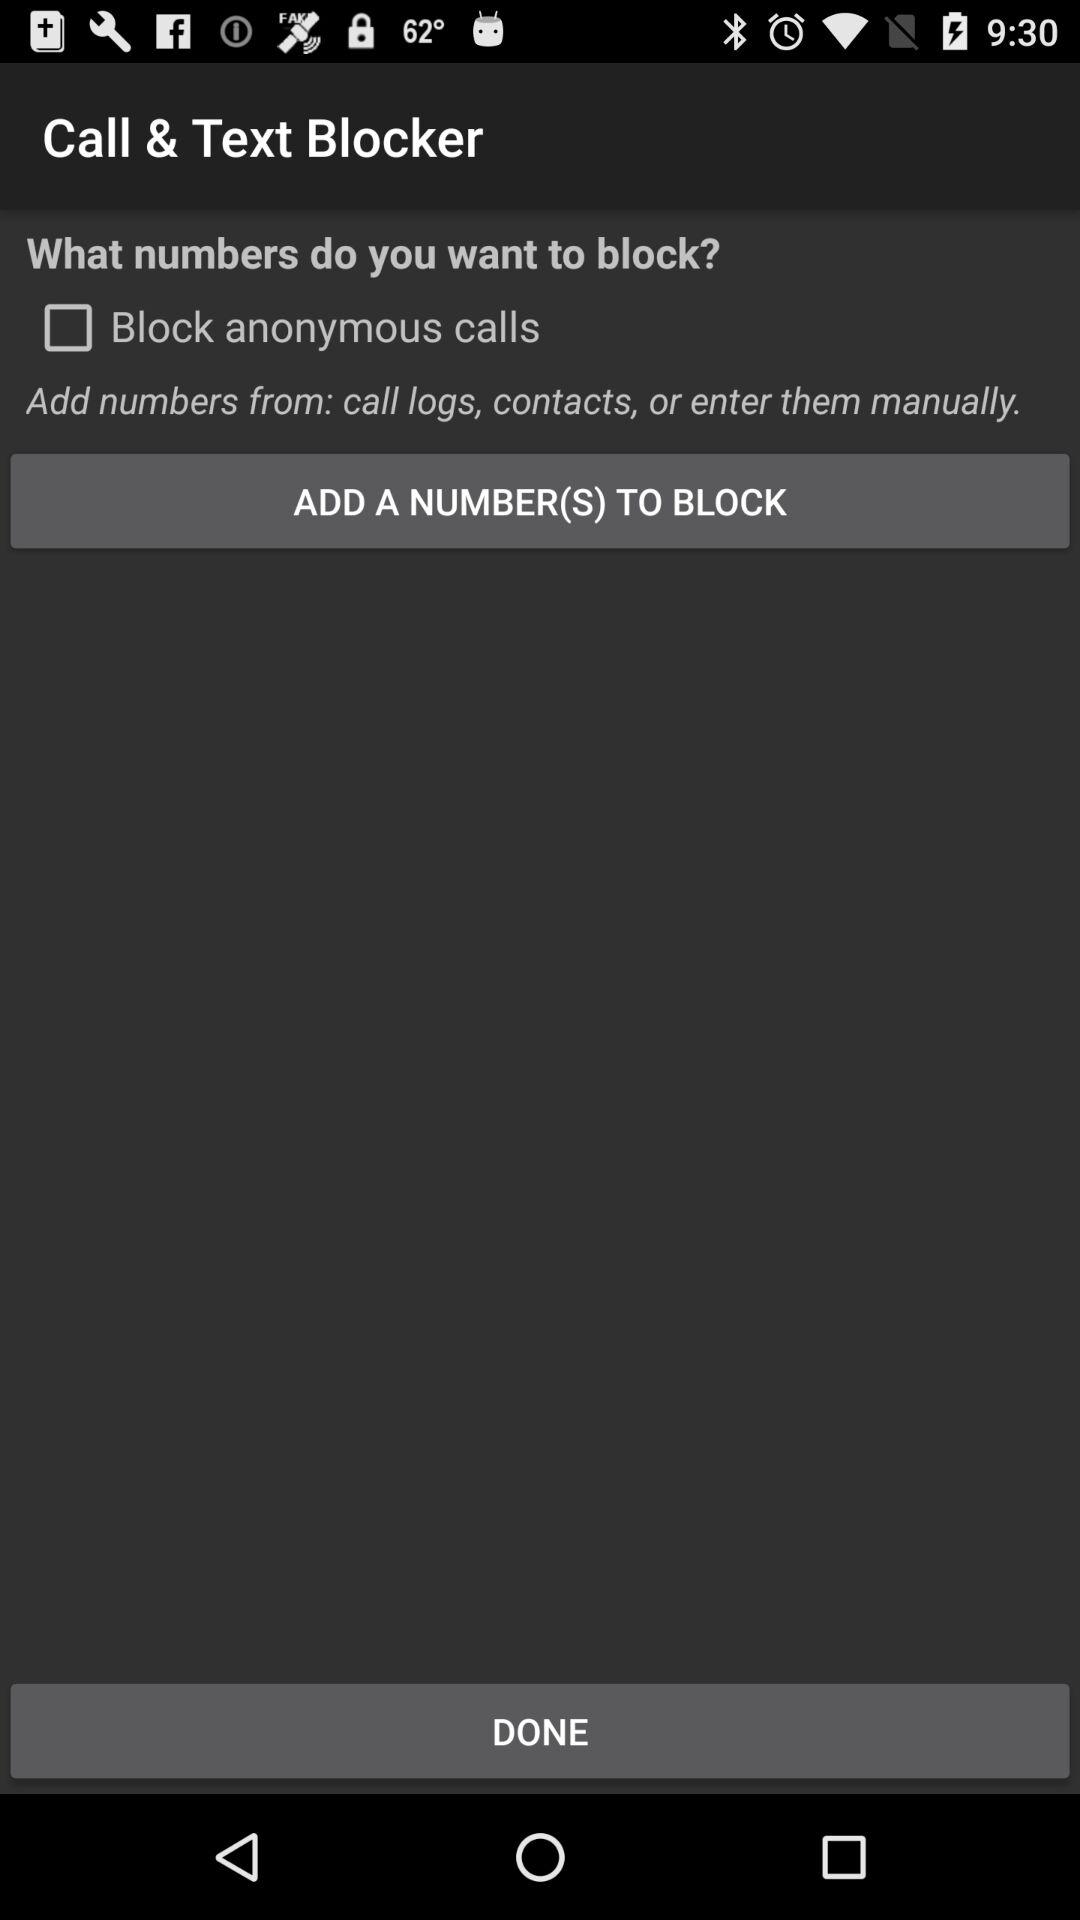What's the status of "Block anonymous calls"? The status is "off". 